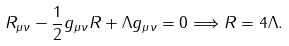Convert formula to latex. <formula><loc_0><loc_0><loc_500><loc_500>R _ { \mu \nu } - \frac { 1 } { 2 } g _ { \mu \nu } R + \Lambda g _ { \mu \nu } = 0 \Longrightarrow R = 4 \Lambda .</formula> 